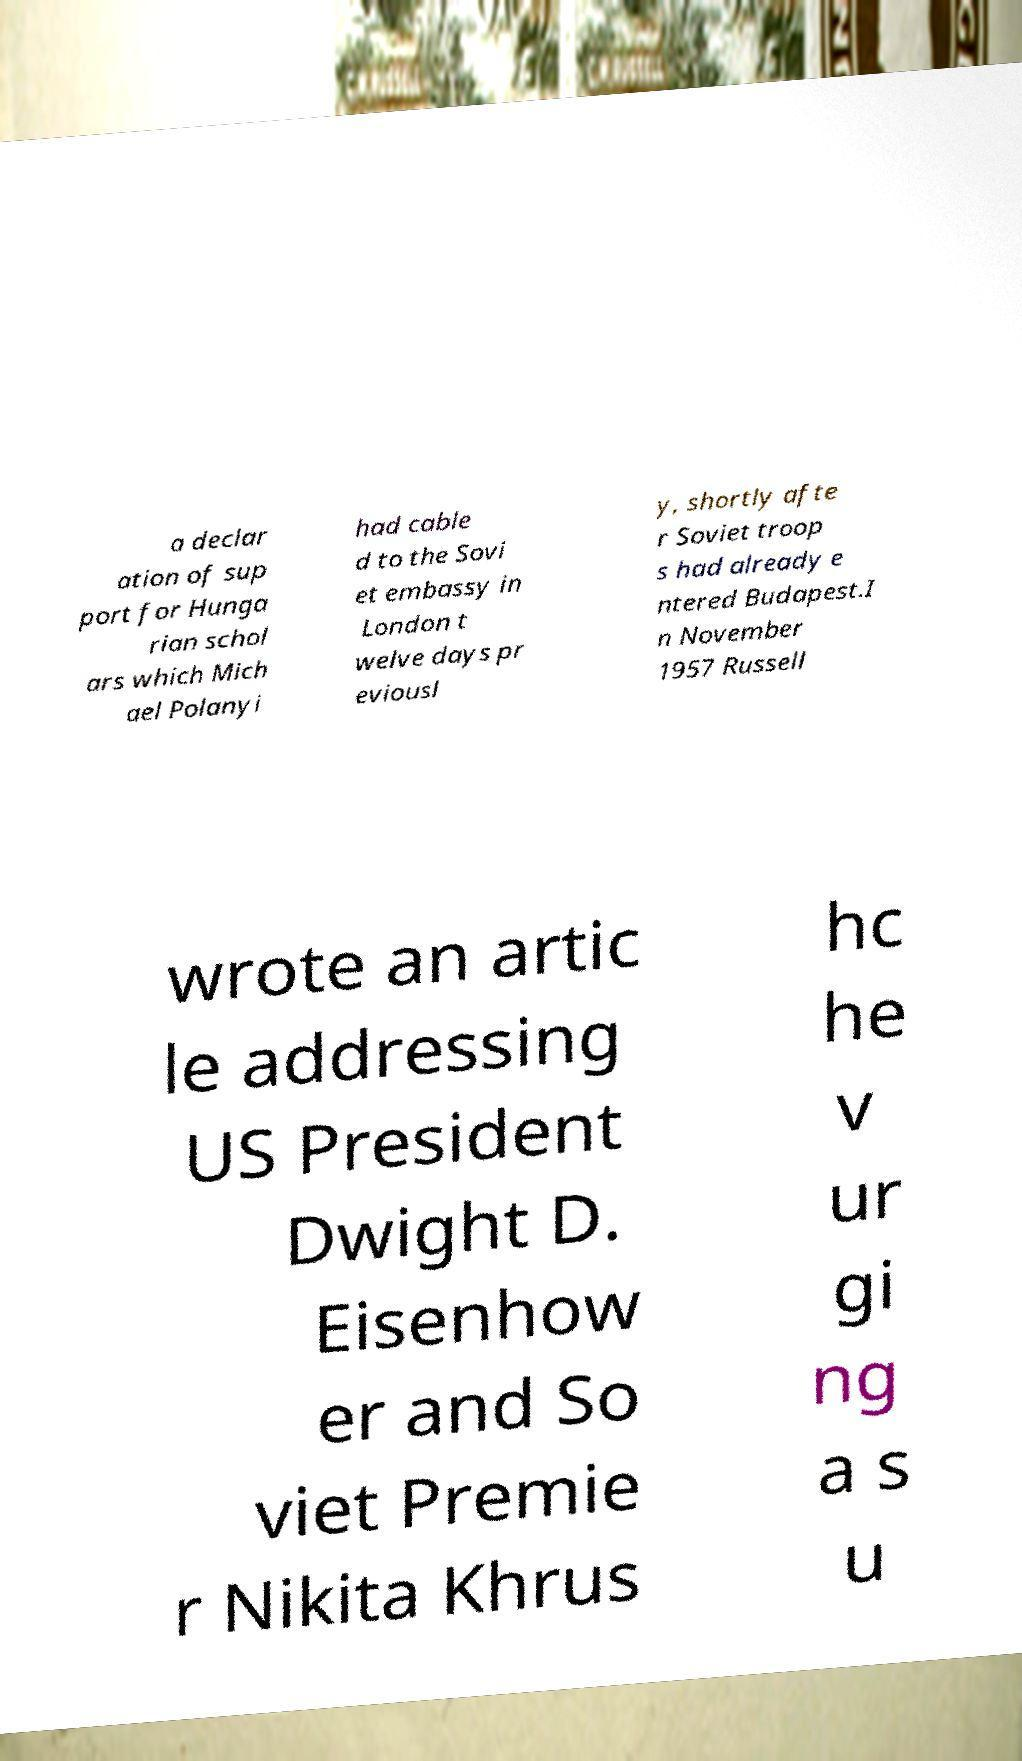Please read and relay the text visible in this image. What does it say? a declar ation of sup port for Hunga rian schol ars which Mich ael Polanyi had cable d to the Sovi et embassy in London t welve days pr eviousl y, shortly afte r Soviet troop s had already e ntered Budapest.I n November 1957 Russell wrote an artic le addressing US President Dwight D. Eisenhow er and So viet Premie r Nikita Khrus hc he v ur gi ng a s u 